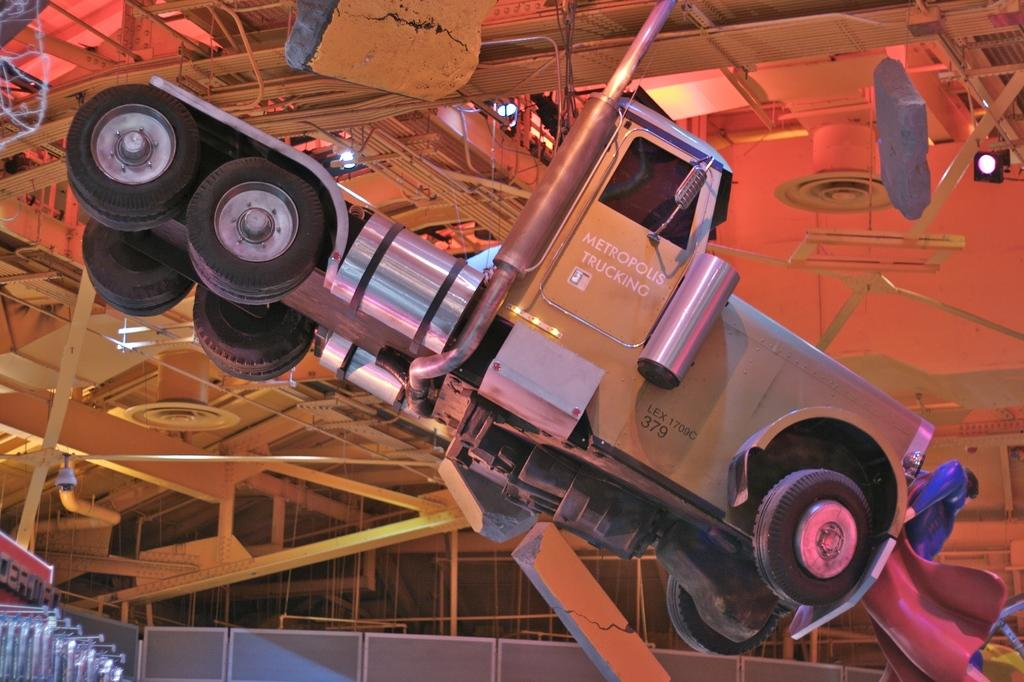What is the main subject in the image? There is a vehicle in the image. What else can be seen in the image besides the vehicle? There are rods to the ceiling in the image. What color is the wall in the image? The wall in the image is grey in color. What type of sign is hanging from the rods in the image? There is no sign present in the image; only rods to the ceiling are visible. 